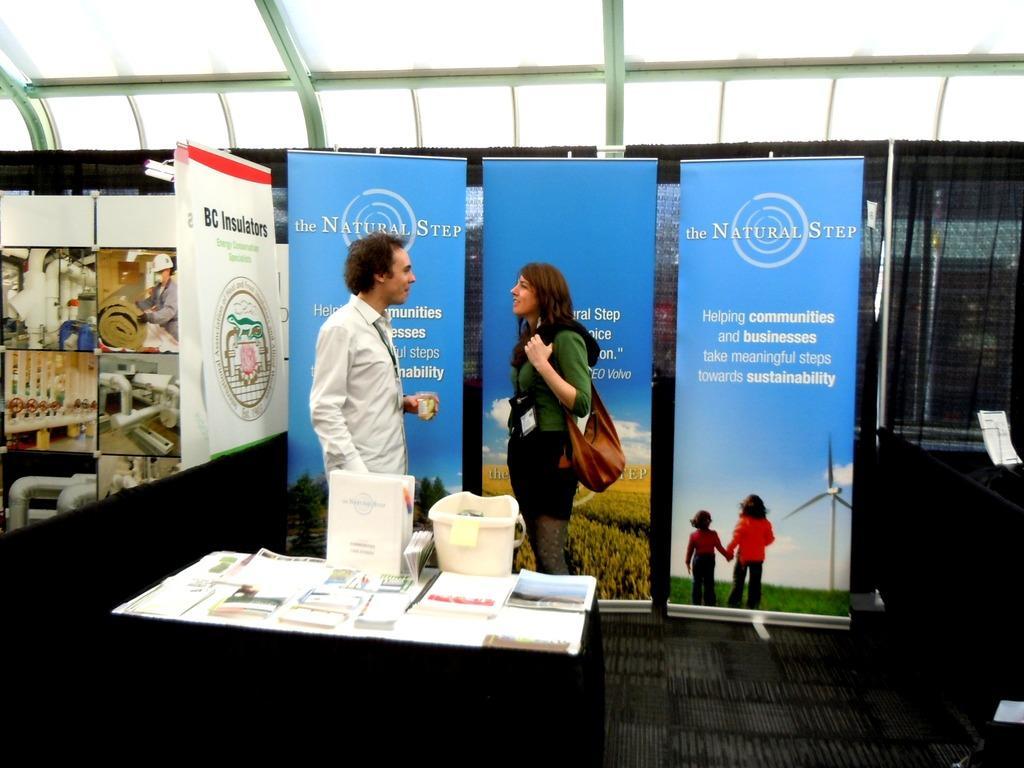Please provide a concise description of this image. In this picture, we can see two people standing, and we can see the ground with some objects like posters, table, and we can see some objects on the table, we can see the glass wall with black curtain attached to a pole. 